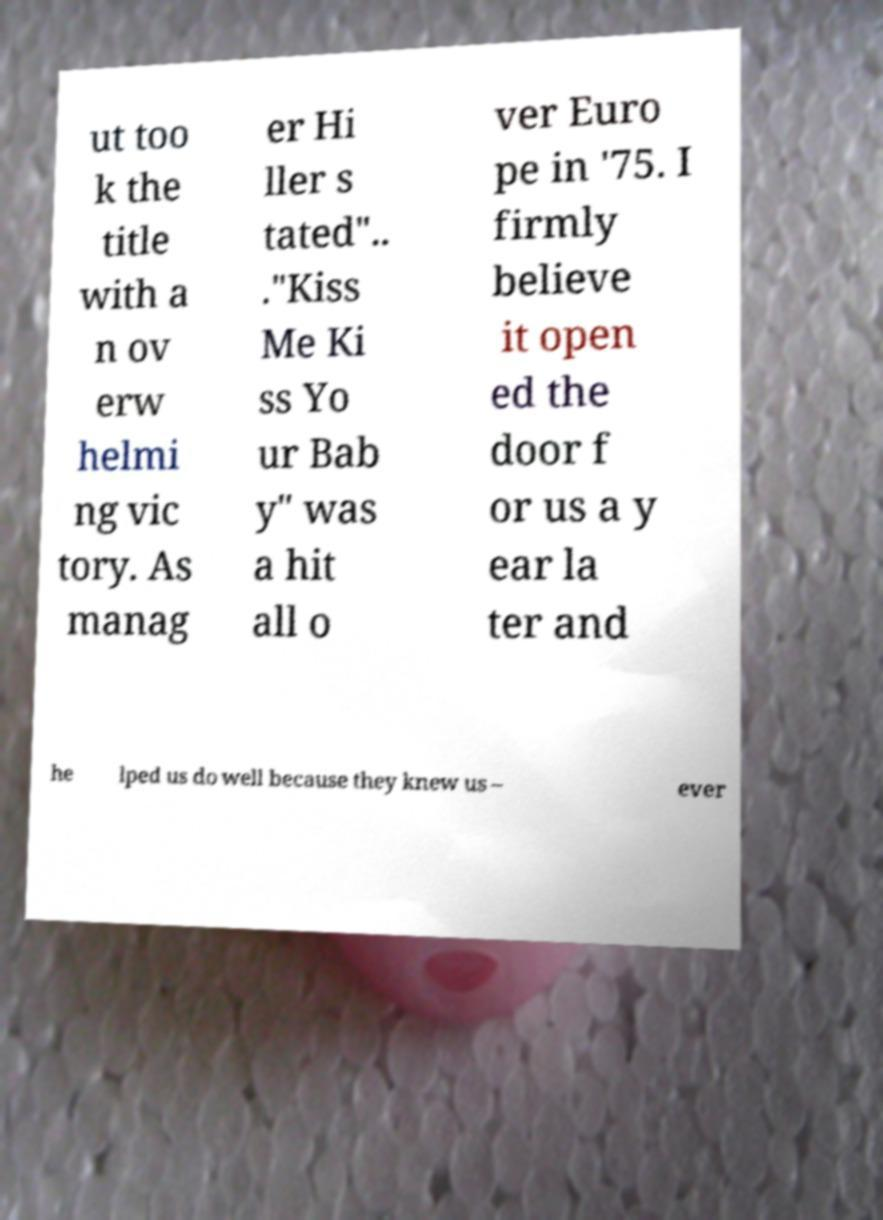Please read and relay the text visible in this image. What does it say? ut too k the title with a n ov erw helmi ng vic tory. As manag er Hi ller s tated".. ."Kiss Me Ki ss Yo ur Bab y" was a hit all o ver Euro pe in '75. I firmly believe it open ed the door f or us a y ear la ter and he lped us do well because they knew us – ever 